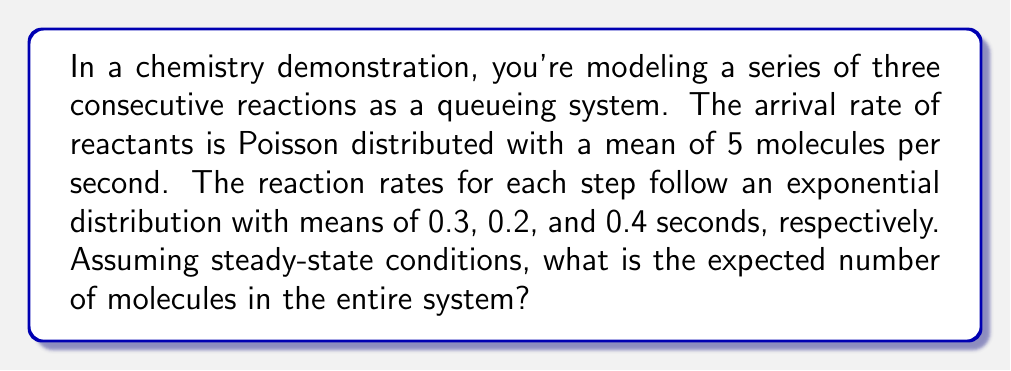Teach me how to tackle this problem. To solve this problem, we can model the chemical reaction system as an M/M/1 queue network with three stages in series. Each stage represents a reaction step.

1. First, let's define our parameters:
   $\lambda$ = arrival rate = 5 molecules/second
   $\mu_1$ = 1/0.3 = 3.33 molecules/second (service rate for first reaction)
   $\mu_2$ = 1/0.2 = 5 molecules/second (service rate for second reaction)
   $\mu_3$ = 1/0.4 = 2.5 molecules/second (service rate for third reaction)

2. For a single M/M/1 queue, the expected number of items in the system is given by:
   $$L = \frac{\rho}{1-\rho}$$
   where $\rho = \frac{\lambda}{\mu}$ (utilization factor)

3. For each stage, we calculate $\rho_i$ and $L_i$:

   Stage 1: $\rho_1 = \frac{5}{3.33} = 1.5$
   Stage 2: $\rho_2 = \frac{5}{5} = 1$
   Stage 3: $\rho_3 = \frac{5}{2.5} = 2$

4. However, we notice that $\rho_1$, $\rho_2$, and $\rho_3$ are all $\geq 1$, which violates the stability condition for queues ($\rho < 1$). This means that in the long run, the system will accumulate an infinite number of molecules.

5. In a real chemical system, this would represent a situation where the reactions can't keep up with the influx of reactants, leading to an accumulation of molecules at each stage.

6. Mathematically, as $\rho \to 1$, $L \to \infty$ for each stage.

7. Therefore, the expected number of molecules in the entire system is the sum of the expected number at each stage, which approaches infinity.
Answer: The expected number of molecules in the entire system approaches infinity, as the system is unstable (arrival rate exceeds service rate at each stage). 